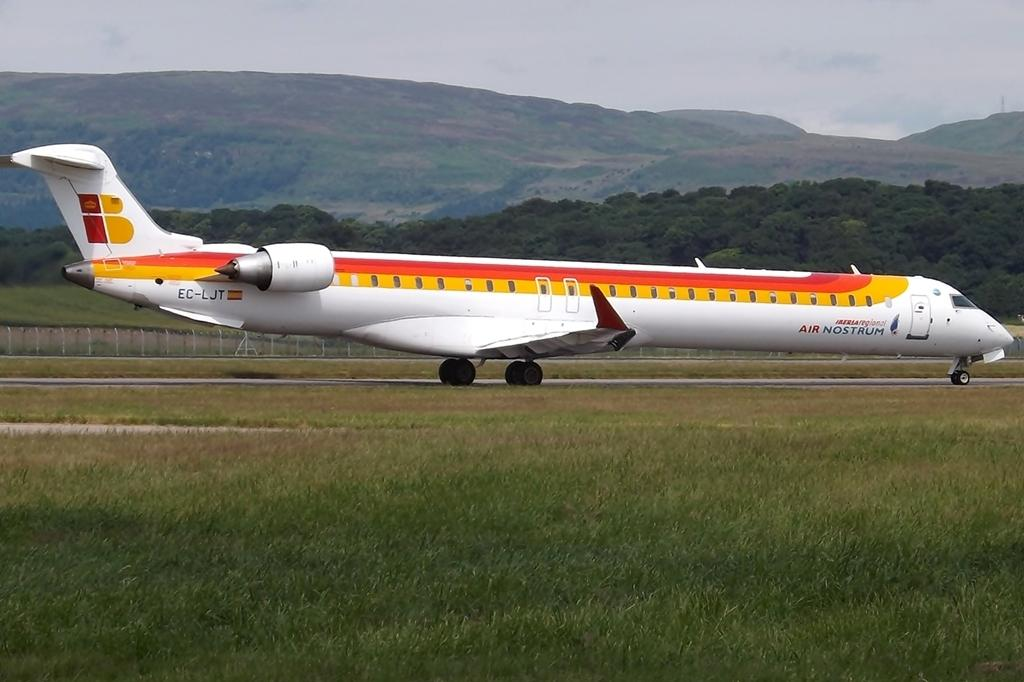Provide a one-sentence caption for the provided image. An Air Nostrum airplane with the lettes EC-LJT on the tail. 